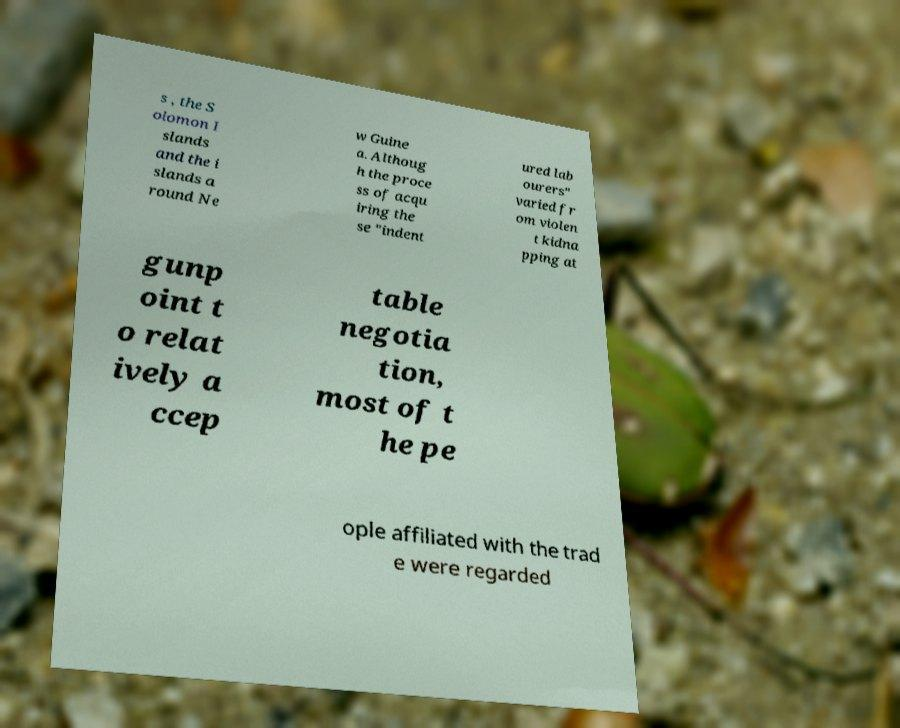Can you read and provide the text displayed in the image?This photo seems to have some interesting text. Can you extract and type it out for me? s , the S olomon I slands and the i slands a round Ne w Guine a. Althoug h the proce ss of acqu iring the se "indent ured lab ourers" varied fr om violen t kidna pping at gunp oint t o relat ively a ccep table negotia tion, most of t he pe ople affiliated with the trad e were regarded 